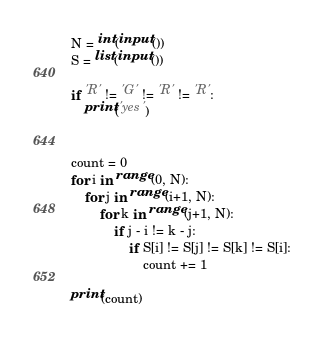<code> <loc_0><loc_0><loc_500><loc_500><_Python_>N = int(input())
S = list(input())

if 'R' != 'G' != 'R' != 'R':
    print('yes')


count = 0
for i in range(0, N):
    for j in range(i+1, N):
        for k in range(j+1, N):
            if j - i != k - j:
                if S[i] != S[j] != S[k] != S[i]:
                    count += 1

print(count)</code> 